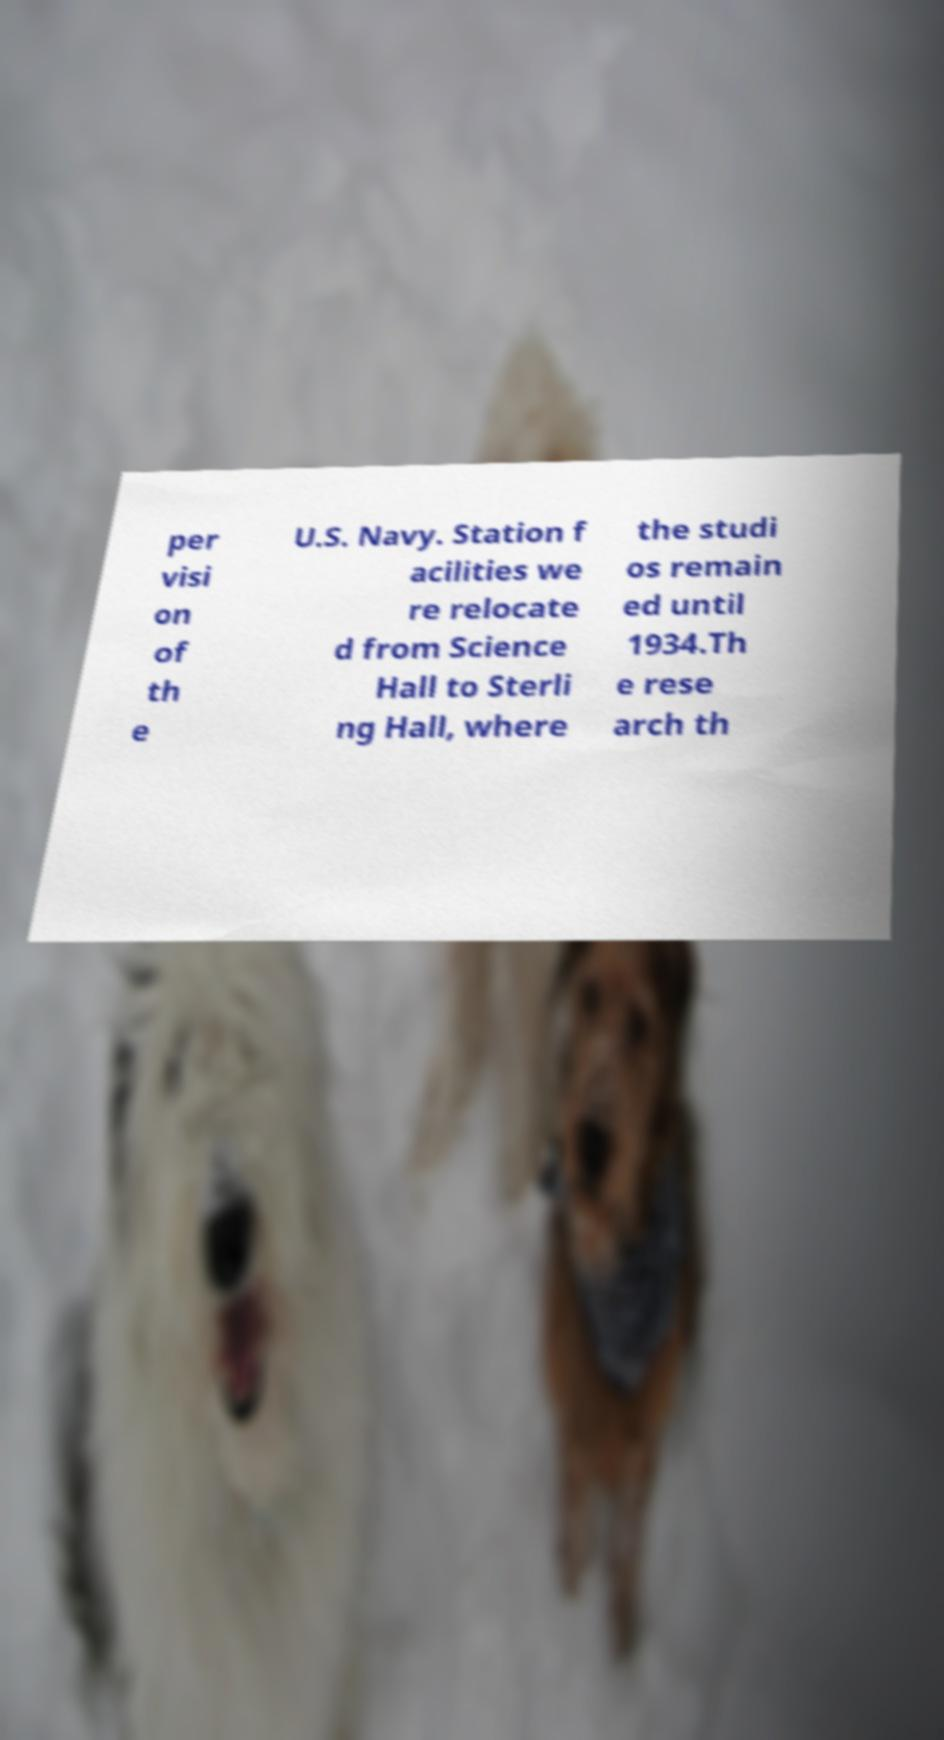Can you read and provide the text displayed in the image?This photo seems to have some interesting text. Can you extract and type it out for me? per visi on of th e U.S. Navy. Station f acilities we re relocate d from Science Hall to Sterli ng Hall, where the studi os remain ed until 1934.Th e rese arch th 